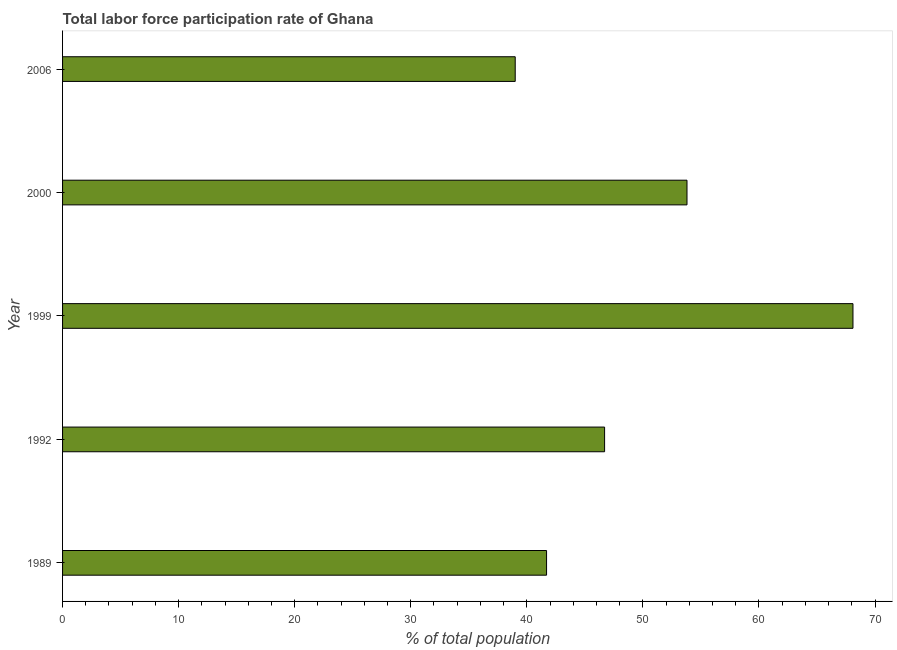What is the title of the graph?
Provide a short and direct response. Total labor force participation rate of Ghana. What is the label or title of the X-axis?
Your answer should be compact. % of total population. What is the total labor force participation rate in 1992?
Provide a succinct answer. 46.7. Across all years, what is the maximum total labor force participation rate?
Keep it short and to the point. 68.1. What is the sum of the total labor force participation rate?
Offer a terse response. 249.3. What is the difference between the total labor force participation rate in 1989 and 1999?
Ensure brevity in your answer.  -26.4. What is the average total labor force participation rate per year?
Offer a very short reply. 49.86. What is the median total labor force participation rate?
Your response must be concise. 46.7. In how many years, is the total labor force participation rate greater than 14 %?
Keep it short and to the point. 5. What is the ratio of the total labor force participation rate in 1999 to that in 2006?
Ensure brevity in your answer.  1.75. Is the total labor force participation rate in 2000 less than that in 2006?
Your answer should be compact. No. What is the difference between the highest and the second highest total labor force participation rate?
Ensure brevity in your answer.  14.3. Is the sum of the total labor force participation rate in 1989 and 2006 greater than the maximum total labor force participation rate across all years?
Make the answer very short. Yes. What is the difference between the highest and the lowest total labor force participation rate?
Ensure brevity in your answer.  29.1. How many bars are there?
Ensure brevity in your answer.  5. Are all the bars in the graph horizontal?
Your answer should be compact. Yes. How many years are there in the graph?
Offer a terse response. 5. What is the difference between two consecutive major ticks on the X-axis?
Your answer should be very brief. 10. Are the values on the major ticks of X-axis written in scientific E-notation?
Make the answer very short. No. What is the % of total population in 1989?
Your answer should be very brief. 41.7. What is the % of total population of 1992?
Make the answer very short. 46.7. What is the % of total population in 1999?
Keep it short and to the point. 68.1. What is the % of total population in 2000?
Offer a terse response. 53.8. What is the difference between the % of total population in 1989 and 1999?
Give a very brief answer. -26.4. What is the difference between the % of total population in 1989 and 2000?
Make the answer very short. -12.1. What is the difference between the % of total population in 1992 and 1999?
Ensure brevity in your answer.  -21.4. What is the difference between the % of total population in 1992 and 2000?
Provide a short and direct response. -7.1. What is the difference between the % of total population in 1992 and 2006?
Give a very brief answer. 7.7. What is the difference between the % of total population in 1999 and 2006?
Ensure brevity in your answer.  29.1. What is the ratio of the % of total population in 1989 to that in 1992?
Give a very brief answer. 0.89. What is the ratio of the % of total population in 1989 to that in 1999?
Provide a succinct answer. 0.61. What is the ratio of the % of total population in 1989 to that in 2000?
Offer a very short reply. 0.78. What is the ratio of the % of total population in 1989 to that in 2006?
Your answer should be very brief. 1.07. What is the ratio of the % of total population in 1992 to that in 1999?
Make the answer very short. 0.69. What is the ratio of the % of total population in 1992 to that in 2000?
Offer a very short reply. 0.87. What is the ratio of the % of total population in 1992 to that in 2006?
Your response must be concise. 1.2. What is the ratio of the % of total population in 1999 to that in 2000?
Keep it short and to the point. 1.27. What is the ratio of the % of total population in 1999 to that in 2006?
Provide a short and direct response. 1.75. What is the ratio of the % of total population in 2000 to that in 2006?
Keep it short and to the point. 1.38. 